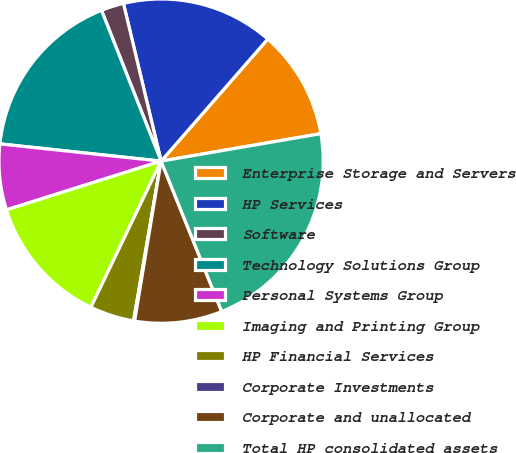Convert chart. <chart><loc_0><loc_0><loc_500><loc_500><pie_chart><fcel>Enterprise Storage and Servers<fcel>HP Services<fcel>Software<fcel>Technology Solutions Group<fcel>Personal Systems Group<fcel>Imaging and Printing Group<fcel>HP Financial Services<fcel>Corporate Investments<fcel>Corporate and unallocated<fcel>Total HP consolidated assets<nl><fcel>10.86%<fcel>15.16%<fcel>2.26%<fcel>17.31%<fcel>6.56%<fcel>13.01%<fcel>4.41%<fcel>0.11%<fcel>8.71%<fcel>21.61%<nl></chart> 